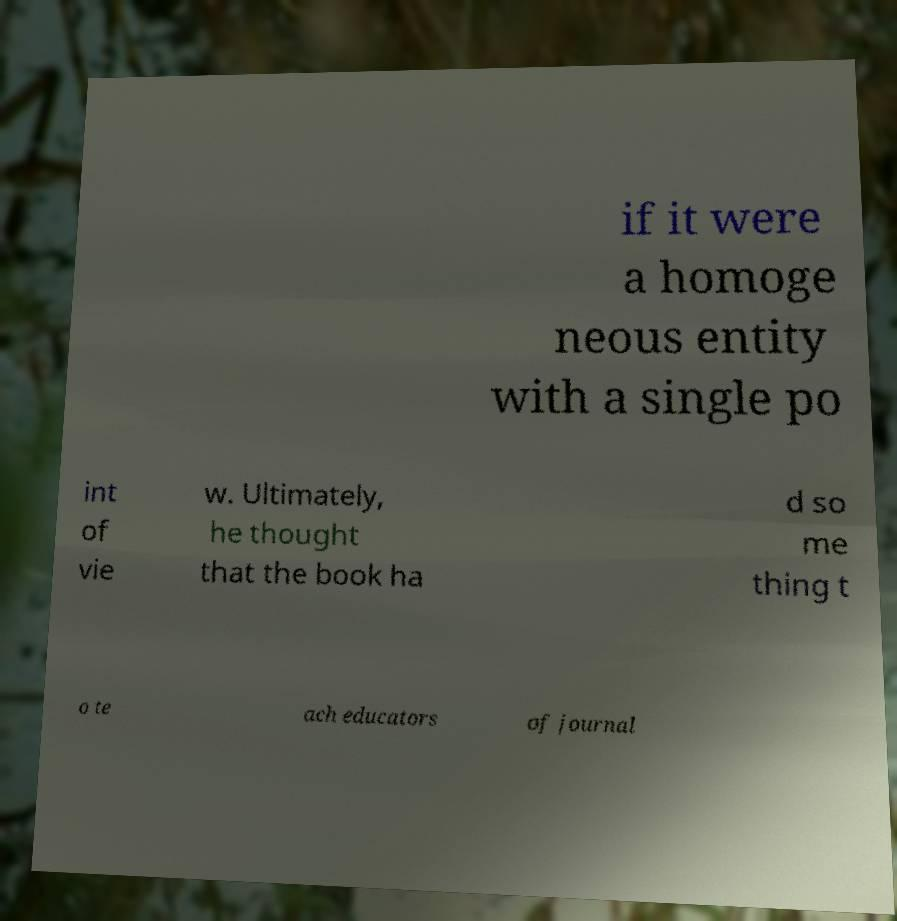Could you extract and type out the text from this image? if it were a homoge neous entity with a single po int of vie w. Ultimately, he thought that the book ha d so me thing t o te ach educators of journal 